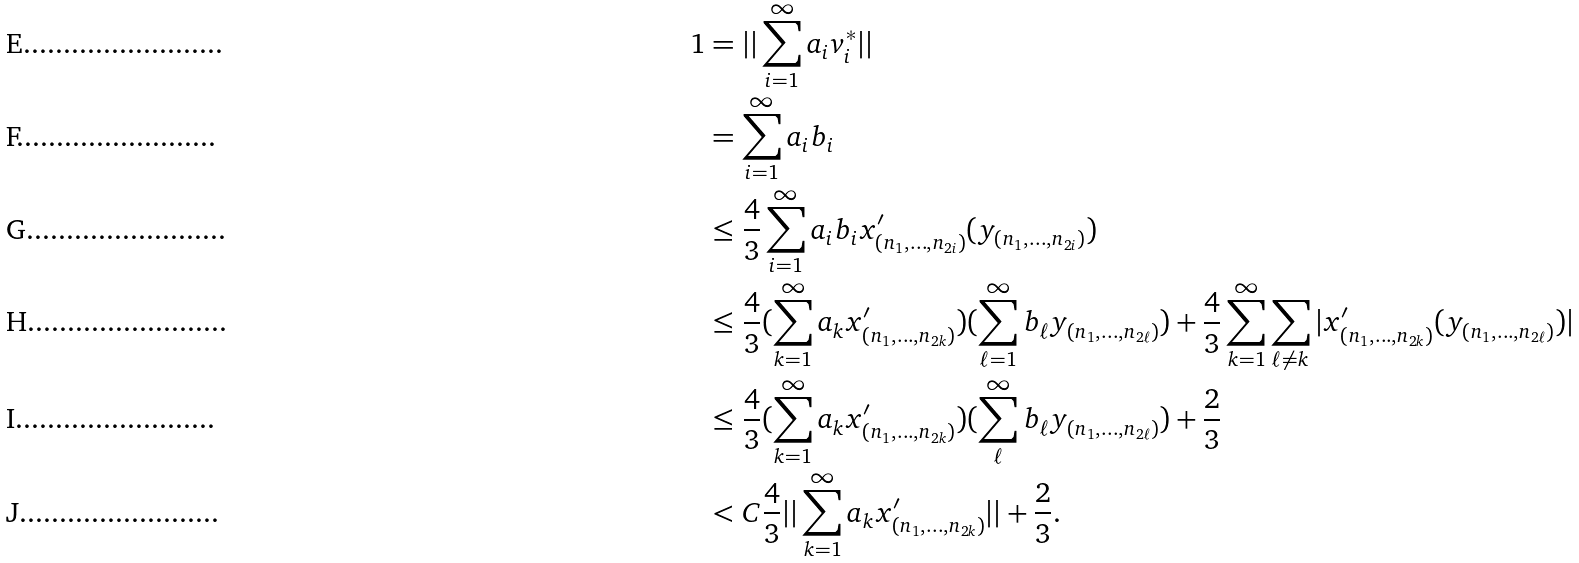Convert formula to latex. <formula><loc_0><loc_0><loc_500><loc_500>1 & = | | \sum _ { i = 1 } ^ { \infty } a _ { i } v _ { i } ^ { * } | | \\ & = \sum _ { i = 1 } ^ { \infty } a _ { i } b _ { i } \\ & \leq \frac { 4 } { 3 } \sum _ { i = 1 } ^ { \infty } a _ { i } b _ { i } x ^ { \prime } _ { ( n _ { 1 } , \dots , n _ { 2 i } ) } ( y _ { ( n _ { 1 } , \dots , n _ { 2 i } ) } ) \\ & \leq \frac { 4 } { 3 } ( \sum _ { k = 1 } ^ { \infty } a _ { k } x ^ { \prime } _ { ( n _ { 1 } , \dots , n _ { 2 k } ) } ) ( \sum _ { \ell = 1 } ^ { \infty } b _ { \ell } y _ { ( n _ { 1 } , \dots , n _ { 2 \ell } ) } ) + \frac { 4 } { 3 } \sum _ { k = 1 } ^ { \infty } \sum _ { \ell \neq k } | x ^ { \prime } _ { ( n _ { 1 } , \dots , n _ { 2 k } ) } ( y _ { ( n _ { 1 } , \dots , n _ { 2 \ell } ) } ) | \\ & \leq \frac { 4 } { 3 } ( \sum _ { k = 1 } ^ { \infty } a _ { k } x ^ { \prime } _ { ( n _ { 1 } , \dots , n _ { 2 k } ) } ) ( \sum _ { \ell } ^ { \infty } b _ { \ell } y _ { ( n _ { 1 } , \dots , n _ { 2 \ell } ) } ) + \frac { 2 } { 3 } \\ & < C \frac { 4 } { 3 } | | \sum _ { k = 1 } ^ { \infty } a _ { k } x ^ { \prime } _ { ( n _ { 1 } , \dots , n _ { 2 k } ) } | | + \frac { 2 } { 3 } .</formula> 